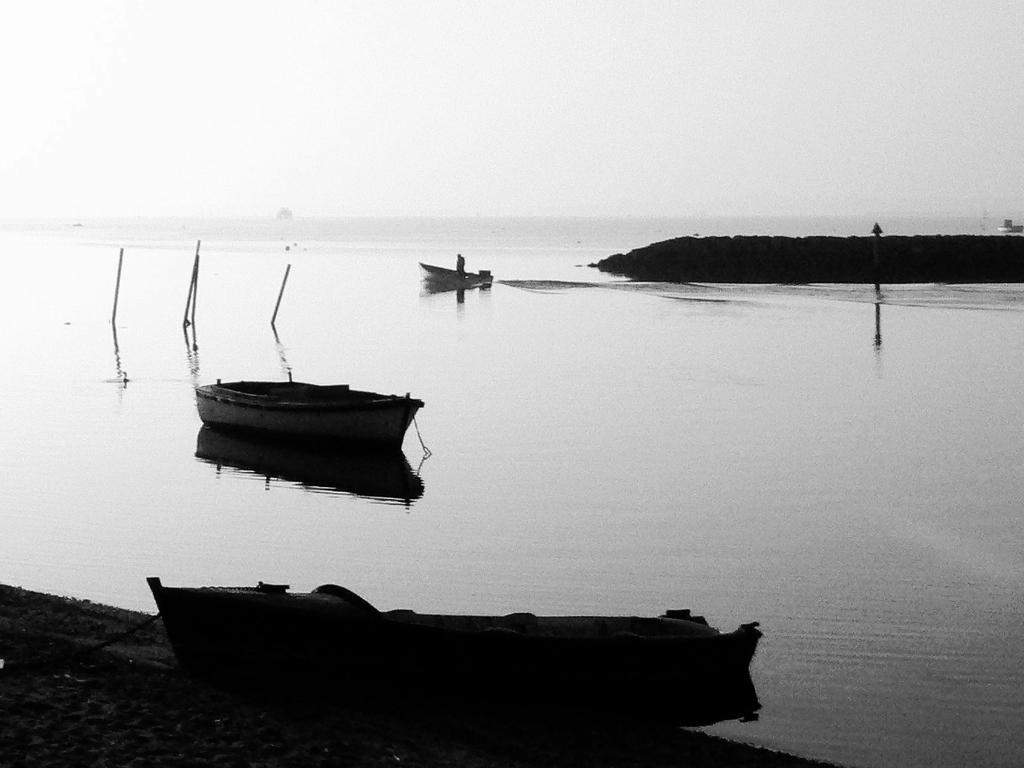What can be seen floating in the water in the image? There are boats in the image. What is the primary element in which the boats are situated? There is water visible in the image. How is the image presented in terms of color? The photography is in black and white. What type of can is visible in the image? There is no can present in the image; it features boats in water. Is there a sink visible in the image? No, there is no sink present in the image. 